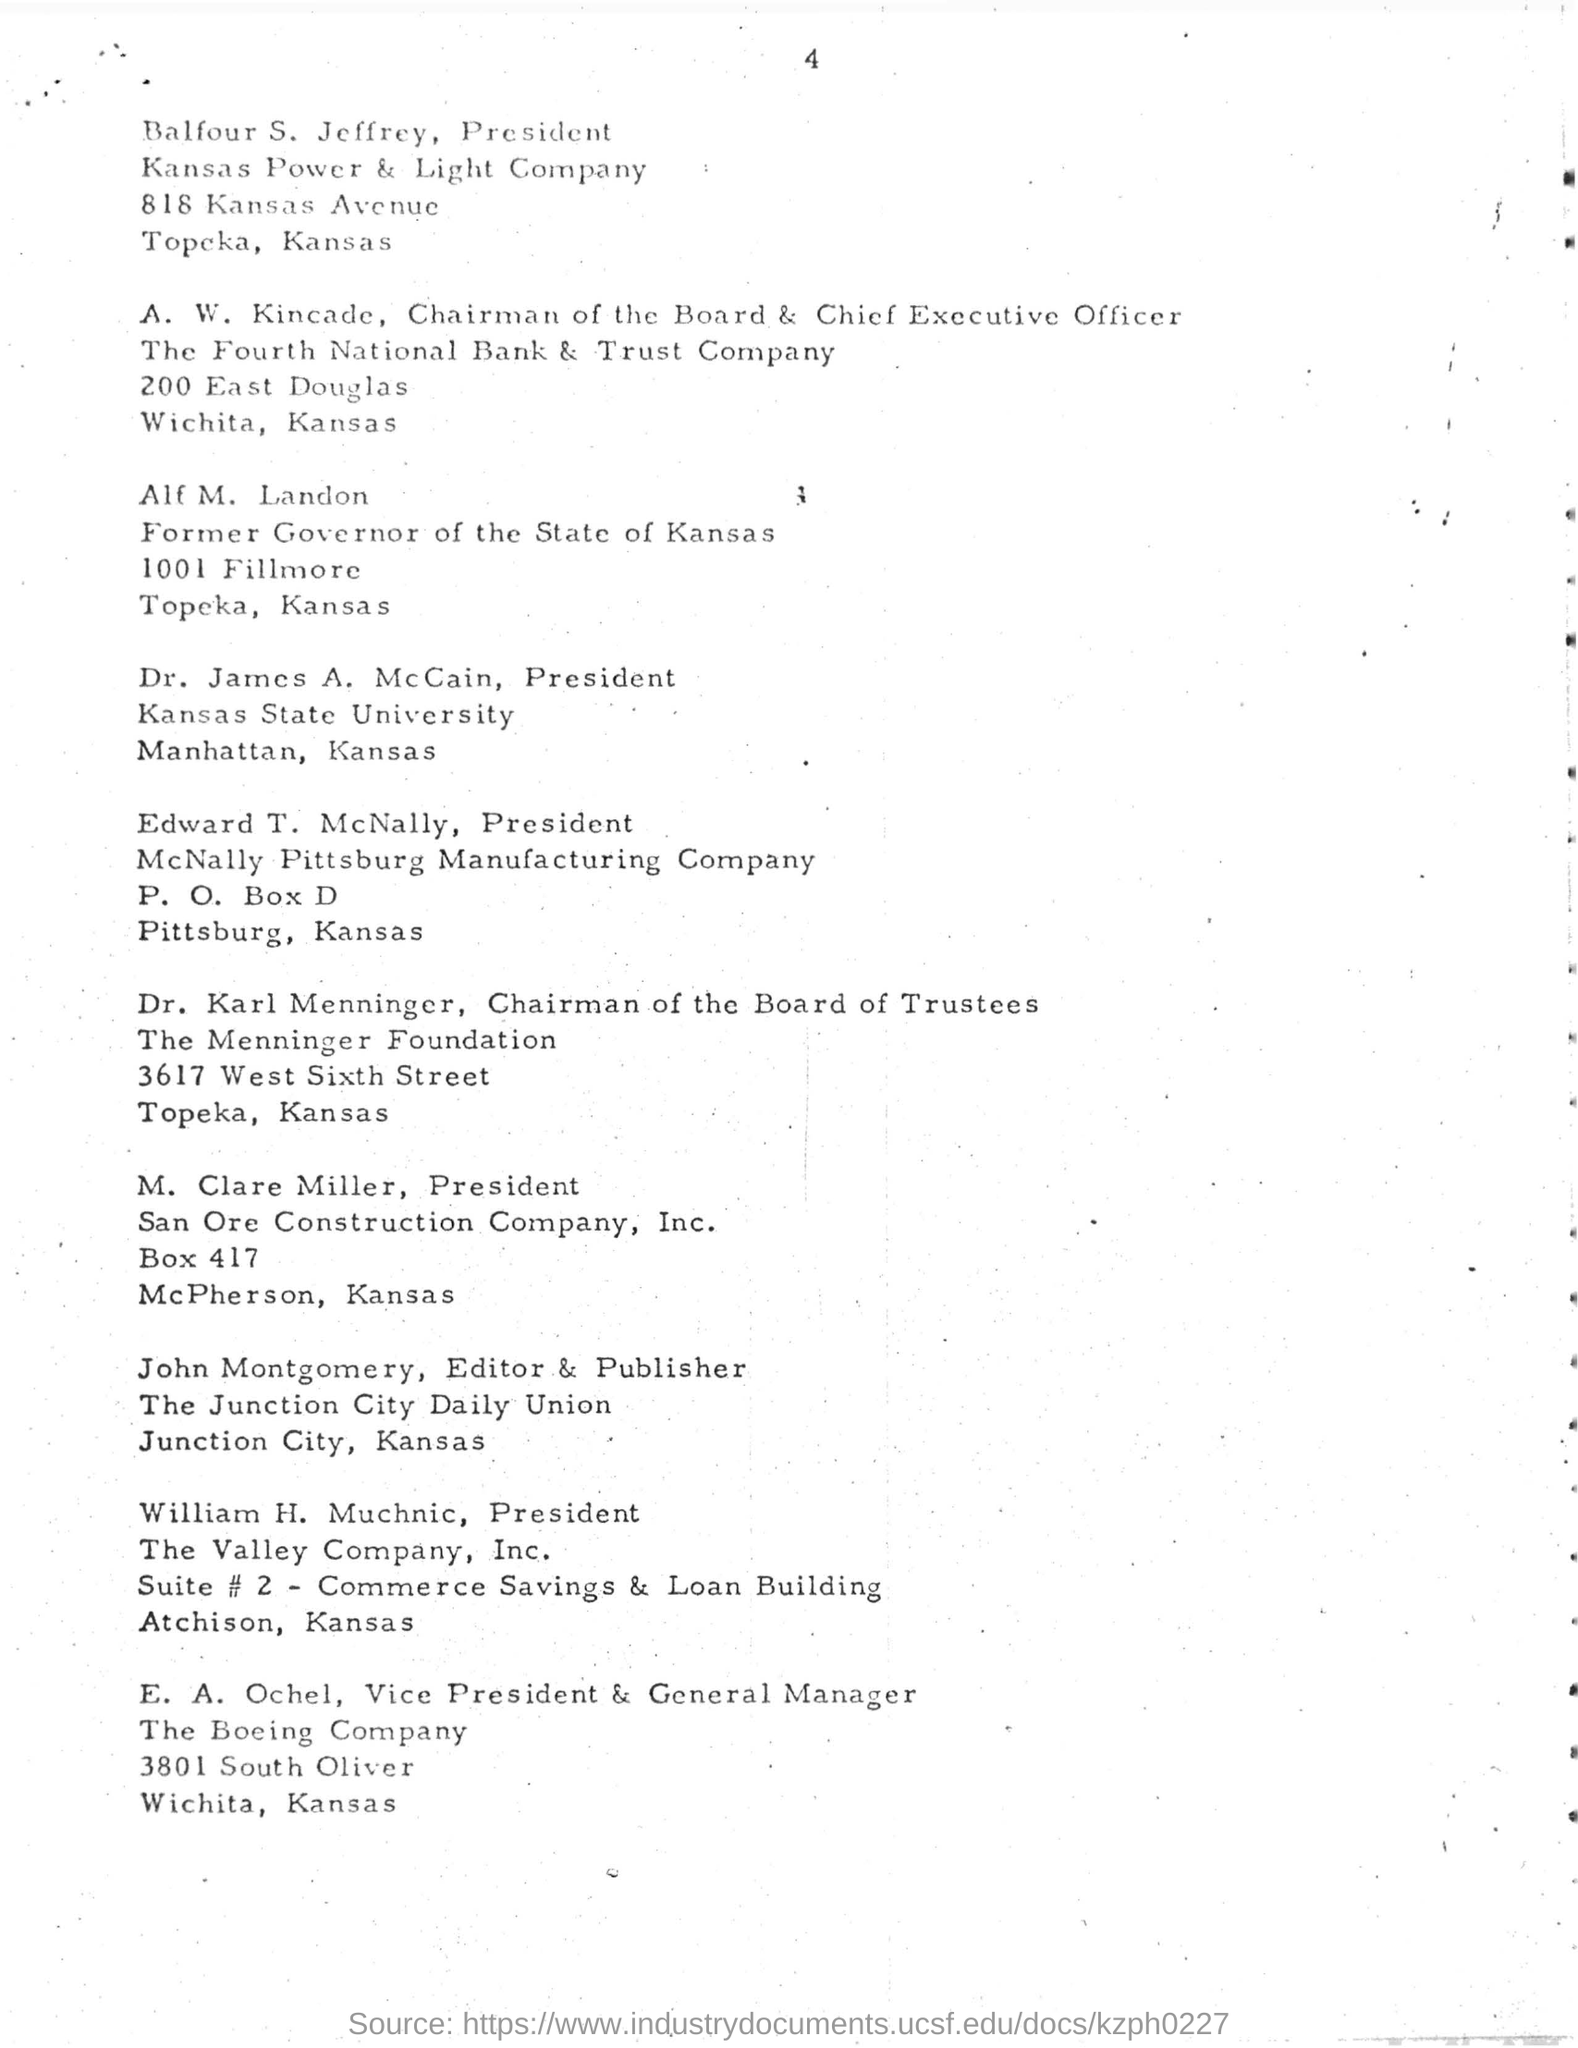Specify some key components in this picture. Alf M. Landon was the former governor of the state of Kansas. Balfour S. Jeffrey is the President of the Kansas Power & Light Company. 